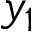Convert formula to latex. <formula><loc_0><loc_0><loc_500><loc_500>y _ { 1 }</formula> 